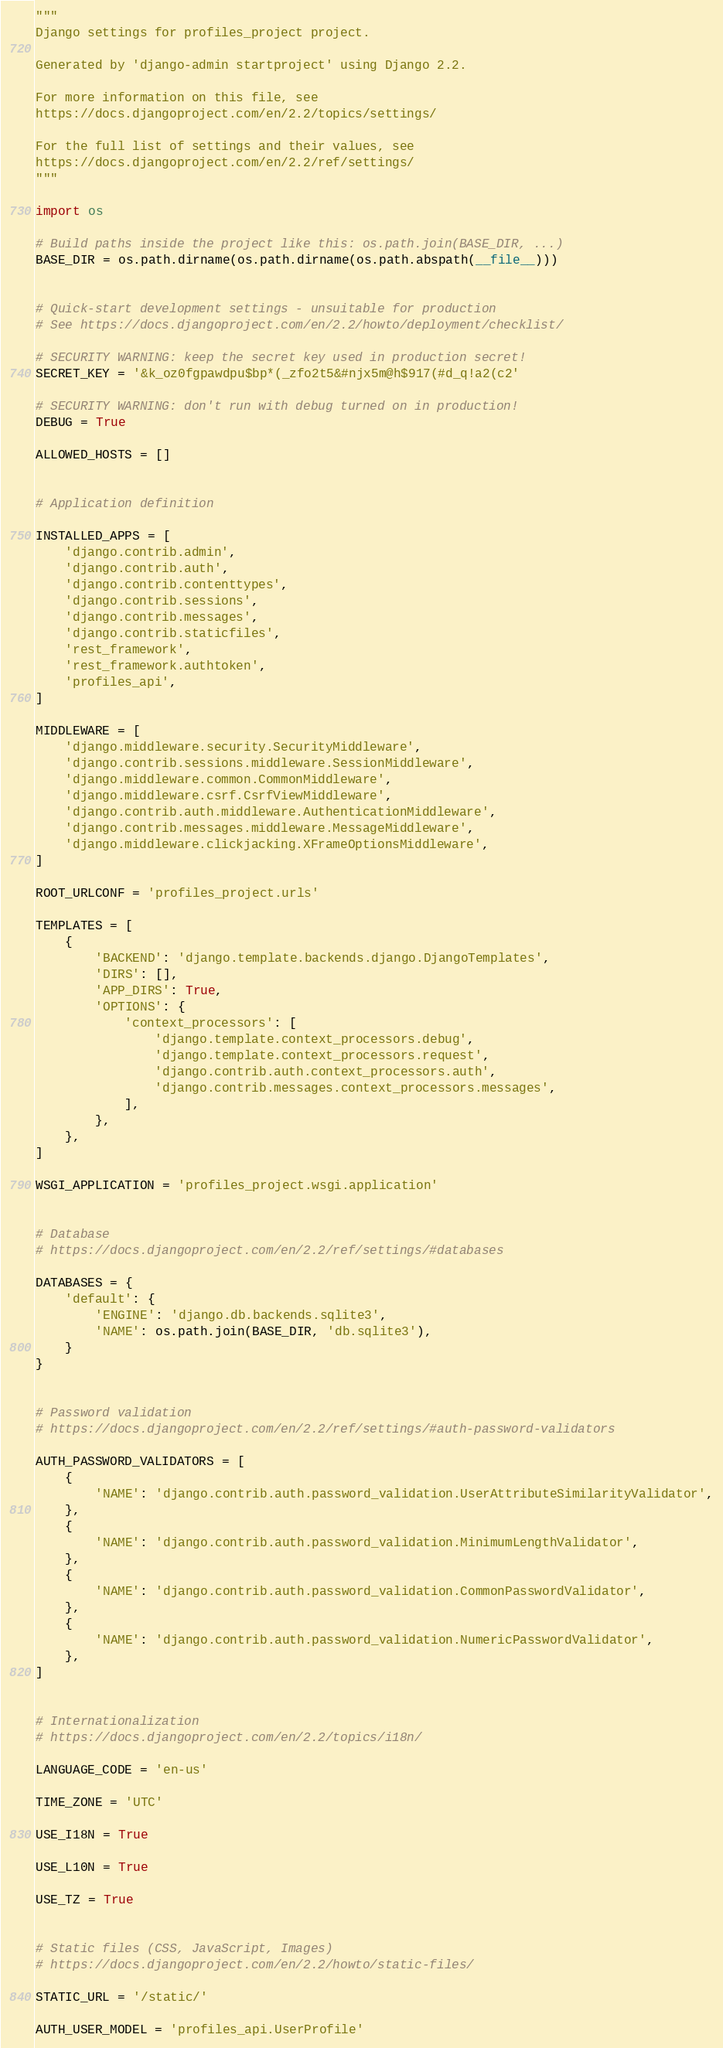Convert code to text. <code><loc_0><loc_0><loc_500><loc_500><_Python_>"""
Django settings for profiles_project project.

Generated by 'django-admin startproject' using Django 2.2.

For more information on this file, see
https://docs.djangoproject.com/en/2.2/topics/settings/

For the full list of settings and their values, see
https://docs.djangoproject.com/en/2.2/ref/settings/
"""

import os

# Build paths inside the project like this: os.path.join(BASE_DIR, ...)
BASE_DIR = os.path.dirname(os.path.dirname(os.path.abspath(__file__)))


# Quick-start development settings - unsuitable for production
# See https://docs.djangoproject.com/en/2.2/howto/deployment/checklist/

# SECURITY WARNING: keep the secret key used in production secret!
SECRET_KEY = '&k_oz0fgpawdpu$bp*(_zfo2t5&#njx5m@h$917(#d_q!a2(c2'

# SECURITY WARNING: don't run with debug turned on in production!
DEBUG = True

ALLOWED_HOSTS = []


# Application definition

INSTALLED_APPS = [
    'django.contrib.admin',
    'django.contrib.auth',
    'django.contrib.contenttypes',
    'django.contrib.sessions',
    'django.contrib.messages',
    'django.contrib.staticfiles',
    'rest_framework',
    'rest_framework.authtoken',
    'profiles_api',
]

MIDDLEWARE = [
    'django.middleware.security.SecurityMiddleware',
    'django.contrib.sessions.middleware.SessionMiddleware',
    'django.middleware.common.CommonMiddleware',
    'django.middleware.csrf.CsrfViewMiddleware',
    'django.contrib.auth.middleware.AuthenticationMiddleware',
    'django.contrib.messages.middleware.MessageMiddleware',
    'django.middleware.clickjacking.XFrameOptionsMiddleware',
]

ROOT_URLCONF = 'profiles_project.urls'

TEMPLATES = [
    {
        'BACKEND': 'django.template.backends.django.DjangoTemplates',
        'DIRS': [],
        'APP_DIRS': True,
        'OPTIONS': {
            'context_processors': [
                'django.template.context_processors.debug',
                'django.template.context_processors.request',
                'django.contrib.auth.context_processors.auth',
                'django.contrib.messages.context_processors.messages',
            ],
        },
    },
]

WSGI_APPLICATION = 'profiles_project.wsgi.application'


# Database
# https://docs.djangoproject.com/en/2.2/ref/settings/#databases

DATABASES = {
    'default': {
        'ENGINE': 'django.db.backends.sqlite3',
        'NAME': os.path.join(BASE_DIR, 'db.sqlite3'),
    }
}


# Password validation
# https://docs.djangoproject.com/en/2.2/ref/settings/#auth-password-validators

AUTH_PASSWORD_VALIDATORS = [
    {
        'NAME': 'django.contrib.auth.password_validation.UserAttributeSimilarityValidator',
    },
    {
        'NAME': 'django.contrib.auth.password_validation.MinimumLengthValidator',
    },
    {
        'NAME': 'django.contrib.auth.password_validation.CommonPasswordValidator',
    },
    {
        'NAME': 'django.contrib.auth.password_validation.NumericPasswordValidator',
    },
]


# Internationalization
# https://docs.djangoproject.com/en/2.2/topics/i18n/

LANGUAGE_CODE = 'en-us'

TIME_ZONE = 'UTC'

USE_I18N = True

USE_L10N = True

USE_TZ = True


# Static files (CSS, JavaScript, Images)
# https://docs.djangoproject.com/en/2.2/howto/static-files/

STATIC_URL = '/static/'

AUTH_USER_MODEL = 'profiles_api.UserProfile'
</code> 